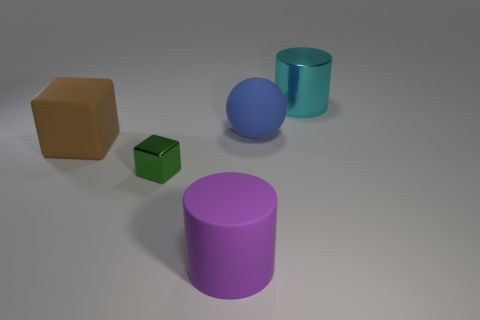There is a small object that is the same shape as the big brown thing; what color is it?
Your answer should be compact. Green. What shape is the object that is behind the big blue thing?
Provide a succinct answer. Cylinder. Are there any big blue rubber objects behind the cyan cylinder?
Give a very brief answer. No. Is there anything else that is the same size as the blue matte sphere?
Offer a terse response. Yes. The thing that is the same material as the cyan cylinder is what color?
Your answer should be very brief. Green. Is the color of the large thing in front of the brown block the same as the large matte object that is left of the small green shiny thing?
Keep it short and to the point. No. How many cylinders are brown things or large purple things?
Ensure brevity in your answer.  1. Are there the same number of big cyan objects on the left side of the small metal cube and big green spheres?
Keep it short and to the point. Yes. What material is the big blue object that is on the left side of the cyan cylinder to the right of the large matte thing that is on the left side of the green thing?
Provide a succinct answer. Rubber. How many things are rubber objects to the left of the green metal object or big gray metal cubes?
Offer a very short reply. 1. 